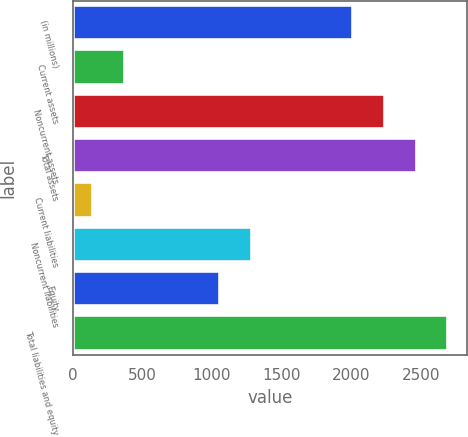Convert chart to OTSL. <chart><loc_0><loc_0><loc_500><loc_500><bar_chart><fcel>(in millions)<fcel>Current assets<fcel>Noncurrent assets<fcel>Total assets<fcel>Current liabilities<fcel>Noncurrent liabilities<fcel>Equity<fcel>Total liabilities and equity<nl><fcel>2011<fcel>373.1<fcel>2240.1<fcel>2469.2<fcel>144<fcel>1290.1<fcel>1061<fcel>2698.3<nl></chart> 